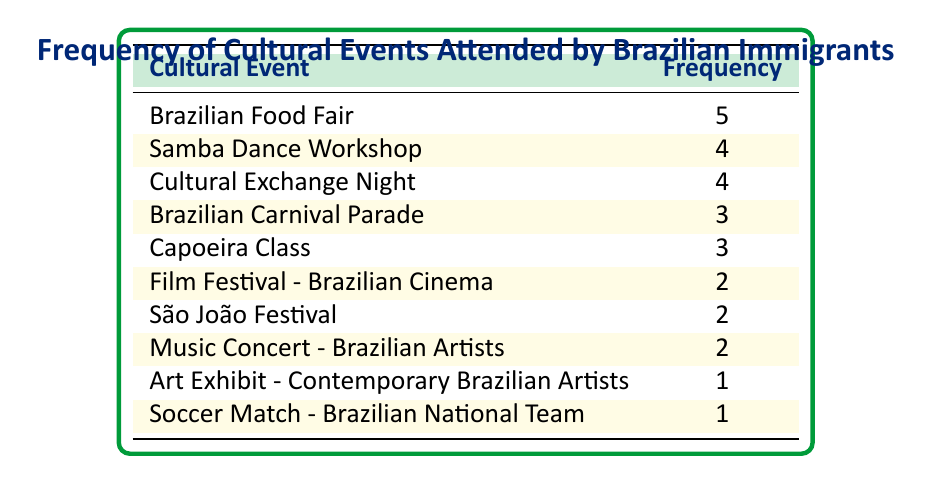What is the event with the highest frequency? The highest frequency is found in the "Brazilian Food Fair," which has a frequency of 5.
Answer: Brazilian Food Fair How many events had a frequency of 2? There are three events that had a frequency of 2: "Film Festival - Brazilian Cinema," "São João Festival," and "Music Concert - Brazilian Artists."
Answer: 3 What is the total frequency of cultural events attended? To find the total frequency, we add up all the frequencies: 5 + 4 + 4 + 3 + 3 + 2 + 2 + 2 + 1 + 1 = 27.
Answer: 27 Is "Capoeira Class" attended more frequently than "Art Exhibit - Contemporary Brazilian Artists"? Yes, "Capoeira Class" has a frequency of 3 while "Art Exhibit - Contemporary Brazilian Artists" has a frequency of 1, so it is attended more frequently.
Answer: Yes What is the average frequency of the events listed? To find the average, we take the total frequency (27) and divide it by the number of events (10), which gives us an average of 27/10 = 2.7.
Answer: 2.7 Which two events are tied with the same frequency, and what is that frequency? "Brazilian Carnival Parade" and "Capoeira Class" both have a frequency of 3, making them tied.
Answer: Frequency of 3 Identify the least attended event and its frequency. The least attended event in the list is "Art Exhibit - Contemporary Brazilian Artists" with a frequency of 1.
Answer: Art Exhibit - Contemporary Brazilian Artists, Frequency of 1 How many events were attended 4 times or more? There are three events that were attended 4 times or more: "Samba Dance Workshop," "Cultural Exchange Night," and "Brazilian Food Fair."
Answer: 3 What percentage of the events had a frequency of less than 3? There are three events with a frequency less than 3 ("Art Exhibit - Contemporary Brazilian Artists," "Soccer Match - Brazilian National Team") out of 10 events, so the percentage is (2/10) * 100 = 20%.
Answer: 20% 